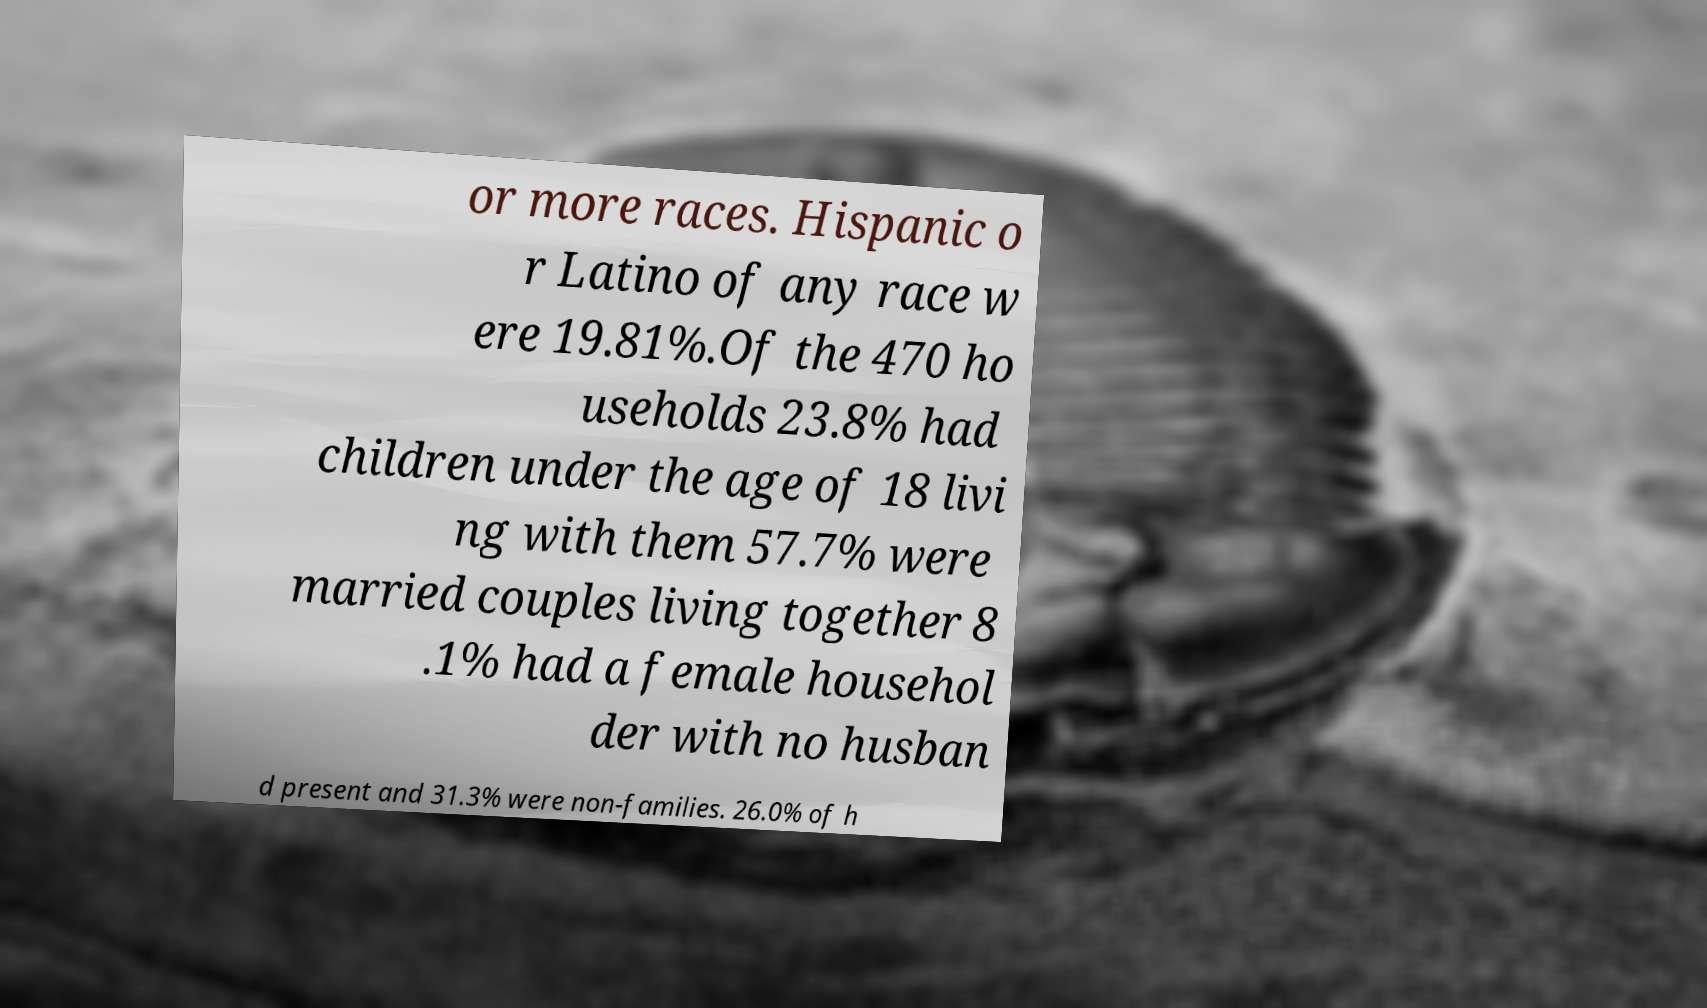For documentation purposes, I need the text within this image transcribed. Could you provide that? or more races. Hispanic o r Latino of any race w ere 19.81%.Of the 470 ho useholds 23.8% had children under the age of 18 livi ng with them 57.7% were married couples living together 8 .1% had a female househol der with no husban d present and 31.3% were non-families. 26.0% of h 